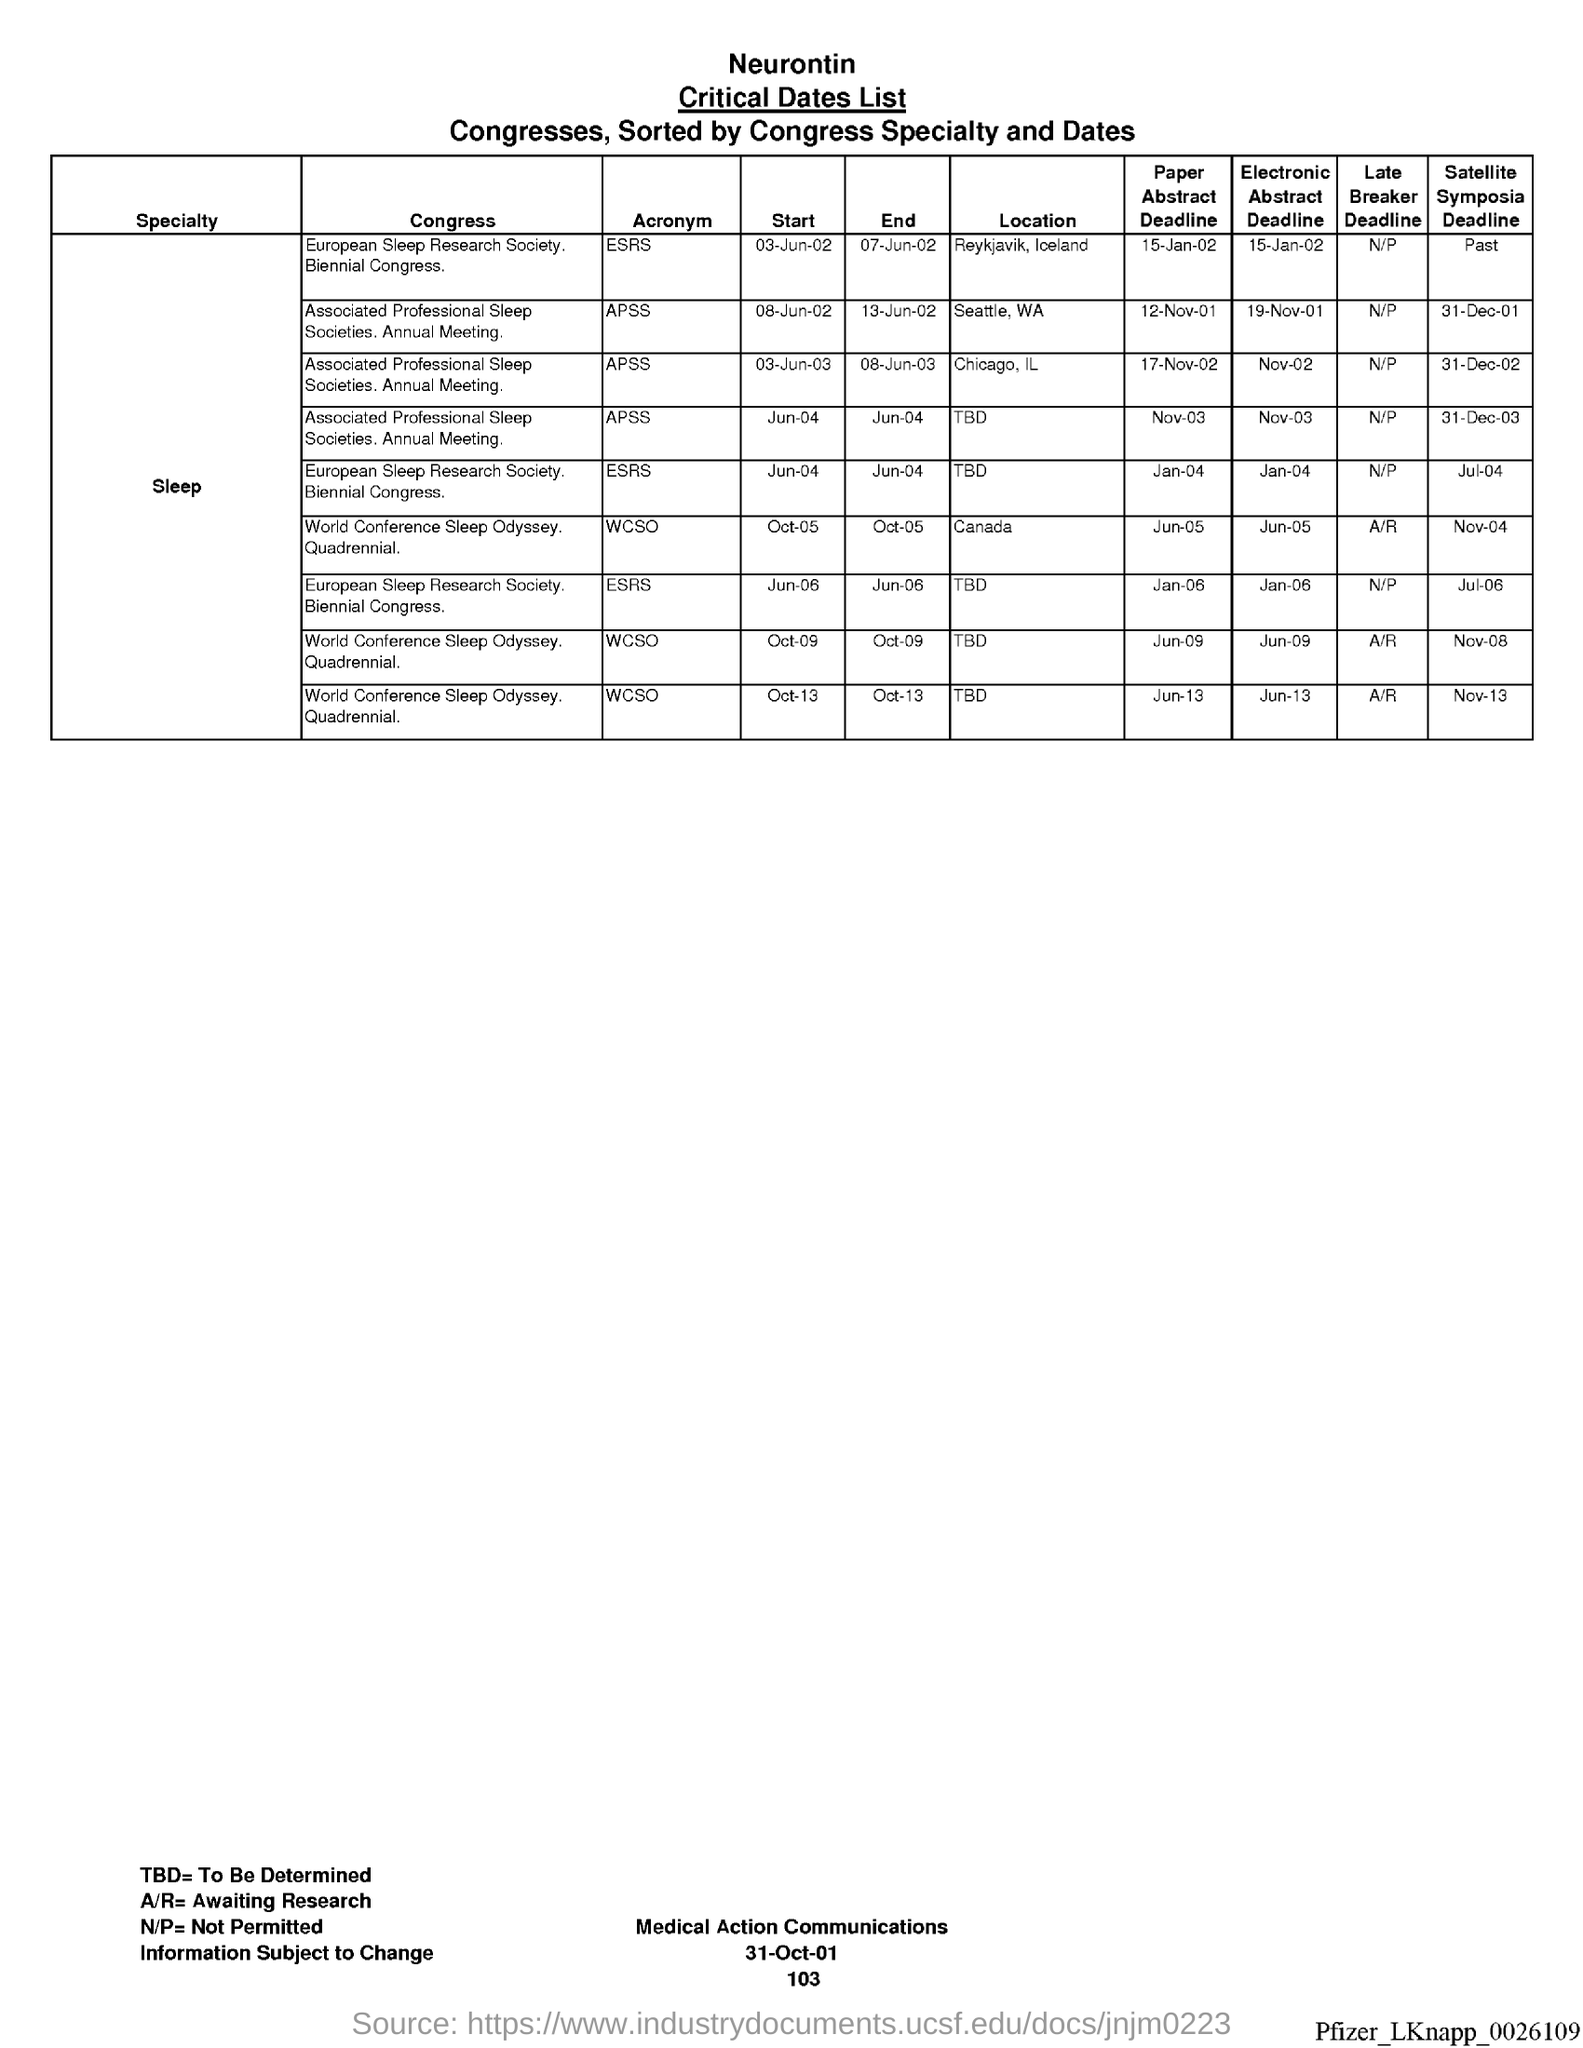Specify some key components in this picture. What is the page number below the date? The date at the bottom of the page is "31-Oct-01". The acronym for Associated Professional Sleep Societies is APS The acronym for World Conference Sleep Odyssey is wcso. The acronym for the European Sleep Research Society is ESRS. 